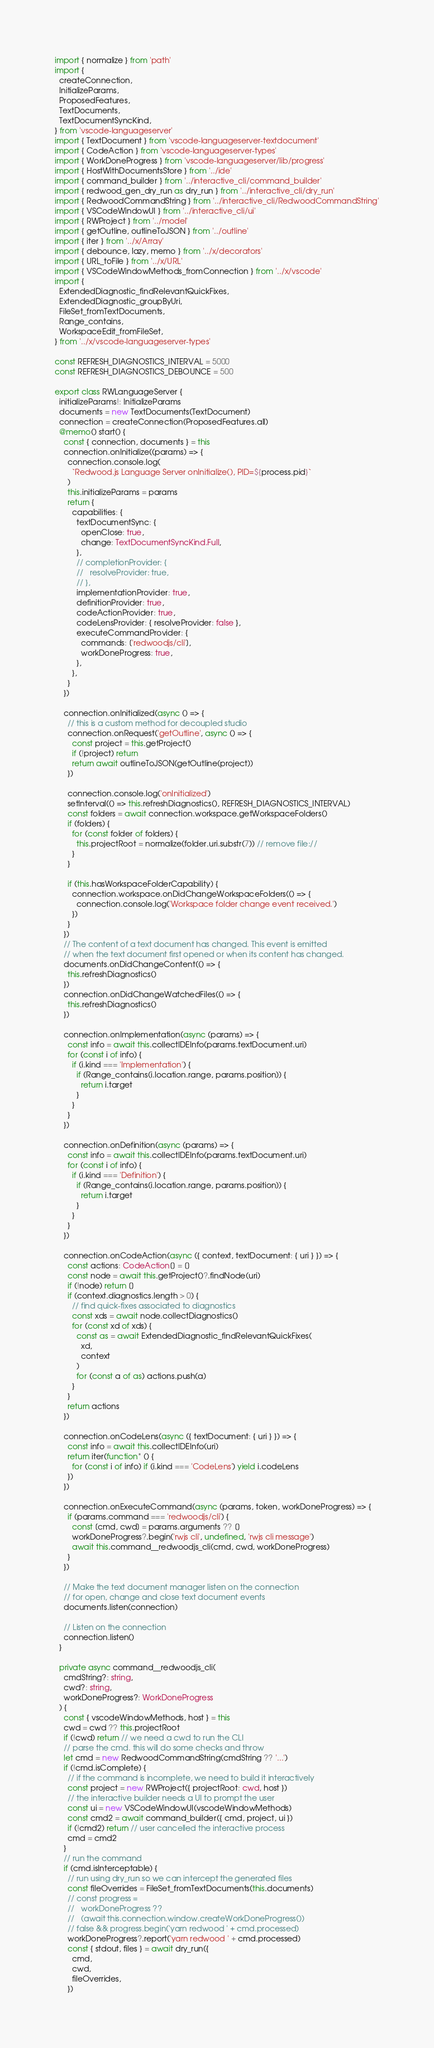Convert code to text. <code><loc_0><loc_0><loc_500><loc_500><_TypeScript_>import { normalize } from 'path'
import {
  createConnection,
  InitializeParams,
  ProposedFeatures,
  TextDocuments,
  TextDocumentSyncKind,
} from 'vscode-languageserver'
import { TextDocument } from 'vscode-languageserver-textdocument'
import { CodeAction } from 'vscode-languageserver-types'
import { WorkDoneProgress } from 'vscode-languageserver/lib/progress'
import { HostWithDocumentsStore } from '../ide'
import { command_builder } from '../interactive_cli/command_builder'
import { redwood_gen_dry_run as dry_run } from '../interactive_cli/dry_run'
import { RedwoodCommandString } from '../interactive_cli/RedwoodCommandString'
import { VSCodeWindowUI } from '../interactive_cli/ui'
import { RWProject } from '../model'
import { getOutline, outlineToJSON } from '../outline'
import { iter } from '../x/Array'
import { debounce, lazy, memo } from '../x/decorators'
import { URL_toFile } from '../x/URL'
import { VSCodeWindowMethods_fromConnection } from '../x/vscode'
import {
  ExtendedDiagnostic_findRelevantQuickFixes,
  ExtendedDiagnostic_groupByUri,
  FileSet_fromTextDocuments,
  Range_contains,
  WorkspaceEdit_fromFileSet,
} from '../x/vscode-languageserver-types'

const REFRESH_DIAGNOSTICS_INTERVAL = 5000
const REFRESH_DIAGNOSTICS_DEBOUNCE = 500

export class RWLanguageServer {
  initializeParams!: InitializeParams
  documents = new TextDocuments(TextDocument)
  connection = createConnection(ProposedFeatures.all)
  @memo() start() {
    const { connection, documents } = this
    connection.onInitialize((params) => {
      connection.console.log(
        `Redwood.js Language Server onInitialize(), PID=${process.pid}`
      )
      this.initializeParams = params
      return {
        capabilities: {
          textDocumentSync: {
            openClose: true,
            change: TextDocumentSyncKind.Full,
          },
          // completionProvider: {
          //   resolveProvider: true,
          // },
          implementationProvider: true,
          definitionProvider: true,
          codeActionProvider: true,
          codeLensProvider: { resolveProvider: false },
          executeCommandProvider: {
            commands: ['redwoodjs/cli'],
            workDoneProgress: true,
          },
        },
      }
    })

    connection.onInitialized(async () => {
      // this is a custom method for decoupled studio
      connection.onRequest('getOutline', async () => {
        const project = this.getProject()
        if (!project) return
        return await outlineToJSON(getOutline(project))
      })

      connection.console.log('onInitialized')
      setInterval(() => this.refreshDiagnostics(), REFRESH_DIAGNOSTICS_INTERVAL)
      const folders = await connection.workspace.getWorkspaceFolders()
      if (folders) {
        for (const folder of folders) {
          this.projectRoot = normalize(folder.uri.substr(7)) // remove file://
        }
      }

      if (this.hasWorkspaceFolderCapability) {
        connection.workspace.onDidChangeWorkspaceFolders(() => {
          connection.console.log('Workspace folder change event received.')
        })
      }
    })
    // The content of a text document has changed. This event is emitted
    // when the text document first opened or when its content has changed.
    documents.onDidChangeContent(() => {
      this.refreshDiagnostics()
    })
    connection.onDidChangeWatchedFiles(() => {
      this.refreshDiagnostics()
    })

    connection.onImplementation(async (params) => {
      const info = await this.collectIDEInfo(params.textDocument.uri)
      for (const i of info) {
        if (i.kind === 'Implementation') {
          if (Range_contains(i.location.range, params.position)) {
            return i.target
          }
        }
      }
    })

    connection.onDefinition(async (params) => {
      const info = await this.collectIDEInfo(params.textDocument.uri)
      for (const i of info) {
        if (i.kind === 'Definition') {
          if (Range_contains(i.location.range, params.position)) {
            return i.target
          }
        }
      }
    })

    connection.onCodeAction(async ({ context, textDocument: { uri } }) => {
      const actions: CodeAction[] = []
      const node = await this.getProject()?.findNode(uri)
      if (!node) return []
      if (context.diagnostics.length > 0) {
        // find quick-fixes associated to diagnostics
        const xds = await node.collectDiagnostics()
        for (const xd of xds) {
          const as = await ExtendedDiagnostic_findRelevantQuickFixes(
            xd,
            context
          )
          for (const a of as) actions.push(a)
        }
      }
      return actions
    })

    connection.onCodeLens(async ({ textDocument: { uri } }) => {
      const info = await this.collectIDEInfo(uri)
      return iter(function* () {
        for (const i of info) if (i.kind === 'CodeLens') yield i.codeLens
      })
    })

    connection.onExecuteCommand(async (params, token, workDoneProgress) => {
      if (params.command === 'redwoodjs/cli') {
        const [cmd, cwd] = params.arguments ?? []
        workDoneProgress?.begin('rwjs cli', undefined, 'rwjs cli message')
        await this.command__redwoodjs_cli(cmd, cwd, workDoneProgress)
      }
    })

    // Make the text document manager listen on the connection
    // for open, change and close text document events
    documents.listen(connection)

    // Listen on the connection
    connection.listen()
  }

  private async command__redwoodjs_cli(
    cmdString?: string,
    cwd?: string,
    workDoneProgress?: WorkDoneProgress
  ) {
    const { vscodeWindowMethods, host } = this
    cwd = cwd ?? this.projectRoot
    if (!cwd) return // we need a cwd to run the CLI
    // parse the cmd. this will do some checks and throw
    let cmd = new RedwoodCommandString(cmdString ?? '...')
    if (!cmd.isComplete) {
      // if the command is incomplete, we need to build it interactively
      const project = new RWProject({ projectRoot: cwd, host })
      // the interactive builder needs a UI to prompt the user
      const ui = new VSCodeWindowUI(vscodeWindowMethods)
      const cmd2 = await command_builder({ cmd, project, ui })
      if (!cmd2) return // user cancelled the interactive process
      cmd = cmd2
    }
    // run the command
    if (cmd.isInterceptable) {
      // run using dry_run so we can intercept the generated files
      const fileOverrides = FileSet_fromTextDocuments(this.documents)
      // const progress =
      //   workDoneProgress ??
      //   (await this.connection.window.createWorkDoneProgress())
      // false && progress.begin('yarn redwood ' + cmd.processed)
      workDoneProgress?.report('yarn redwood ' + cmd.processed)
      const { stdout, files } = await dry_run({
        cmd,
        cwd,
        fileOverrides,
      })</code> 